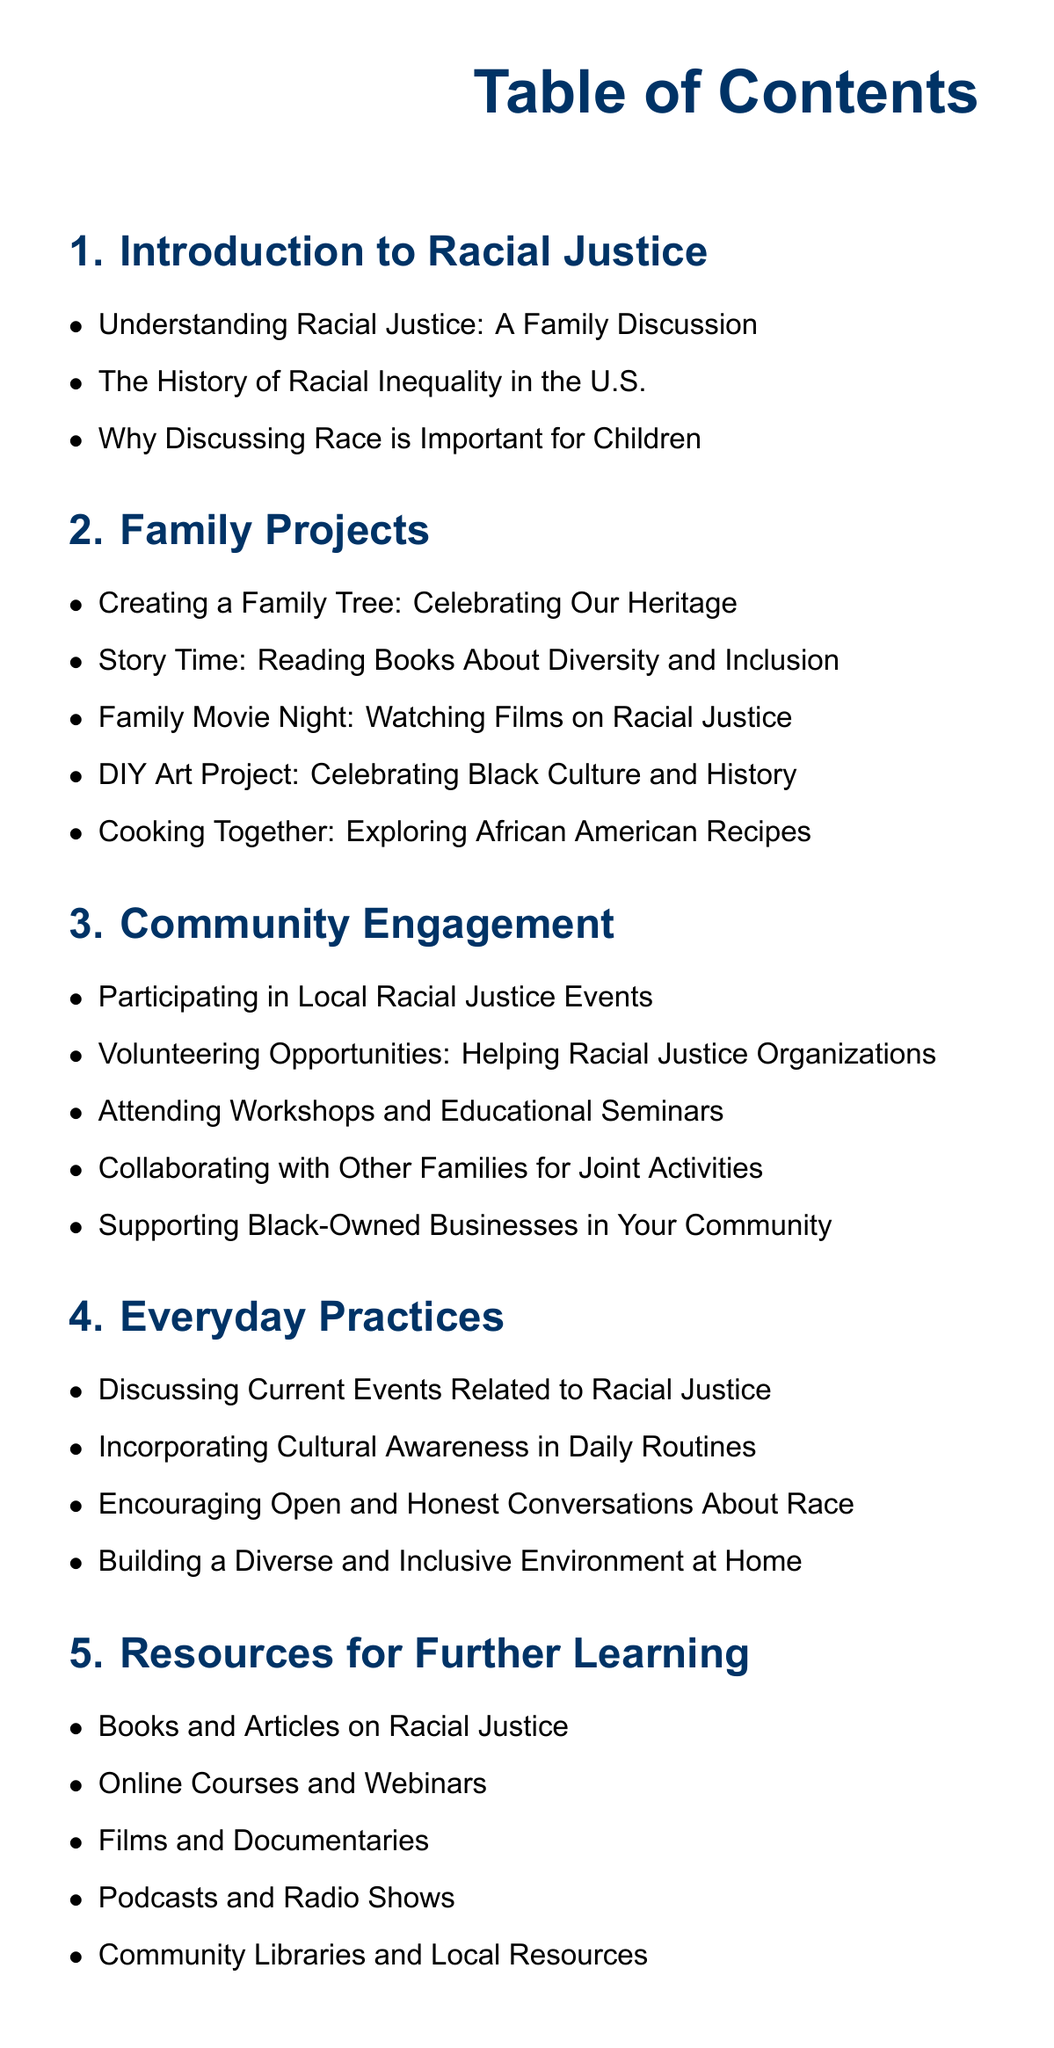what is the first section of the document? The first section listed in the Table of Contents is "Introduction to Racial Justice".
Answer: Introduction to Racial Justice how many family projects are listed? The number of family projects is indicated by counting the items in the "Family Projects" section.
Answer: 5 what is one of the topics under Community Engagement? This requires identifying any specific topic listed in the "Community Engagement" section.
Answer: Supporting Black-Owned Businesses in Your Community what is included in the Everyday Practices section? This involves understanding that the Everyday Practices section lists several practices for addressing racial justice.
Answer: Discussing Current Events Related to Racial Justice name a type of resource recommended for further learning. This question looks for a specific type mentioned in the "Resources for Further Learning" section.
Answer: Online Courses and Webinars 